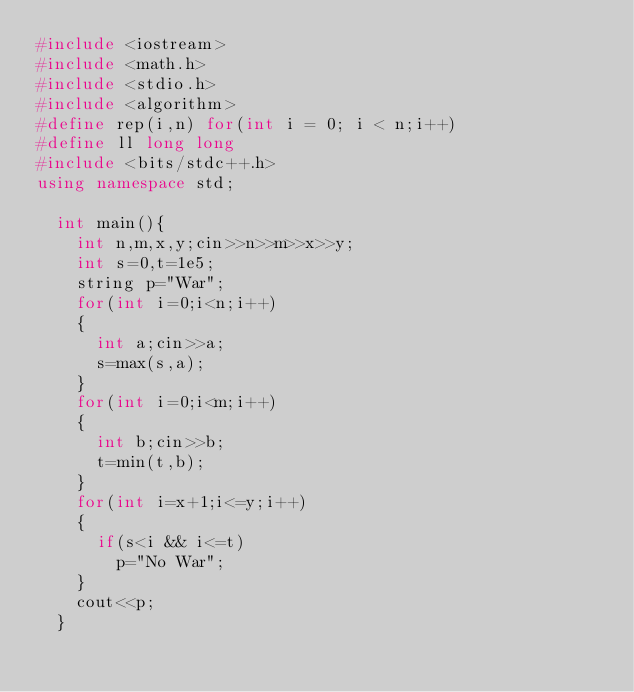<code> <loc_0><loc_0><loc_500><loc_500><_C++_>#include <iostream>
#include <math.h>
#include <stdio.h>
#include <algorithm>
#define rep(i,n) for(int i = 0; i < n;i++)
#define ll long long
#include <bits/stdc++.h>
using namespace std;

  int main(){
    int n,m,x,y;cin>>n>>m>>x>>y;
    int s=0,t=1e5;
    string p="War";
    for(int i=0;i<n;i++)
    {
      int a;cin>>a;
      s=max(s,a);
    }
    for(int i=0;i<m;i++)
    {
      int b;cin>>b;
      t=min(t,b);
    }
    for(int i=x+1;i<=y;i++)
    {
      if(s<i && i<=t)
        p="No War";
    }
    cout<<p;
  }
        
      </code> 